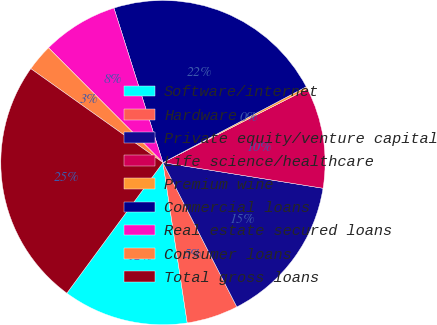Convert chart to OTSL. <chart><loc_0><loc_0><loc_500><loc_500><pie_chart><fcel>Software/internet<fcel>Hardware<fcel>Private equity/venture capital<fcel>Life science/healthcare<fcel>Premium wine<fcel>Commercial loans<fcel>Real estate secured loans<fcel>Consumer loans<fcel>Total gross loans<nl><fcel>12.49%<fcel>5.14%<fcel>14.94%<fcel>10.04%<fcel>0.24%<fcel>22.14%<fcel>7.59%<fcel>2.69%<fcel>24.74%<nl></chart> 